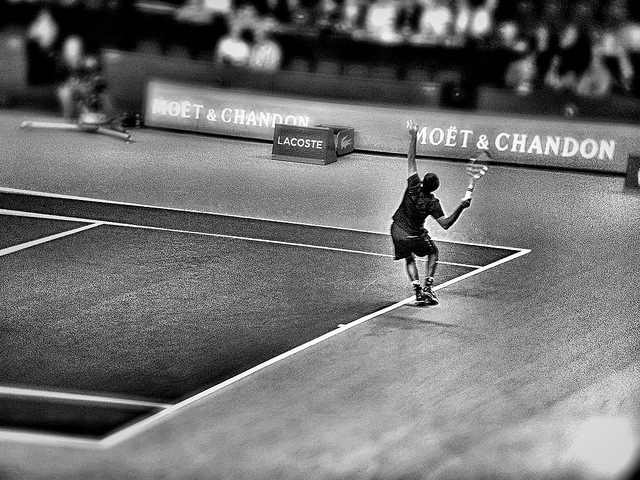Identify the text contained in this image. MOET & CHANDON MOET CHANDON LACOSTE & 